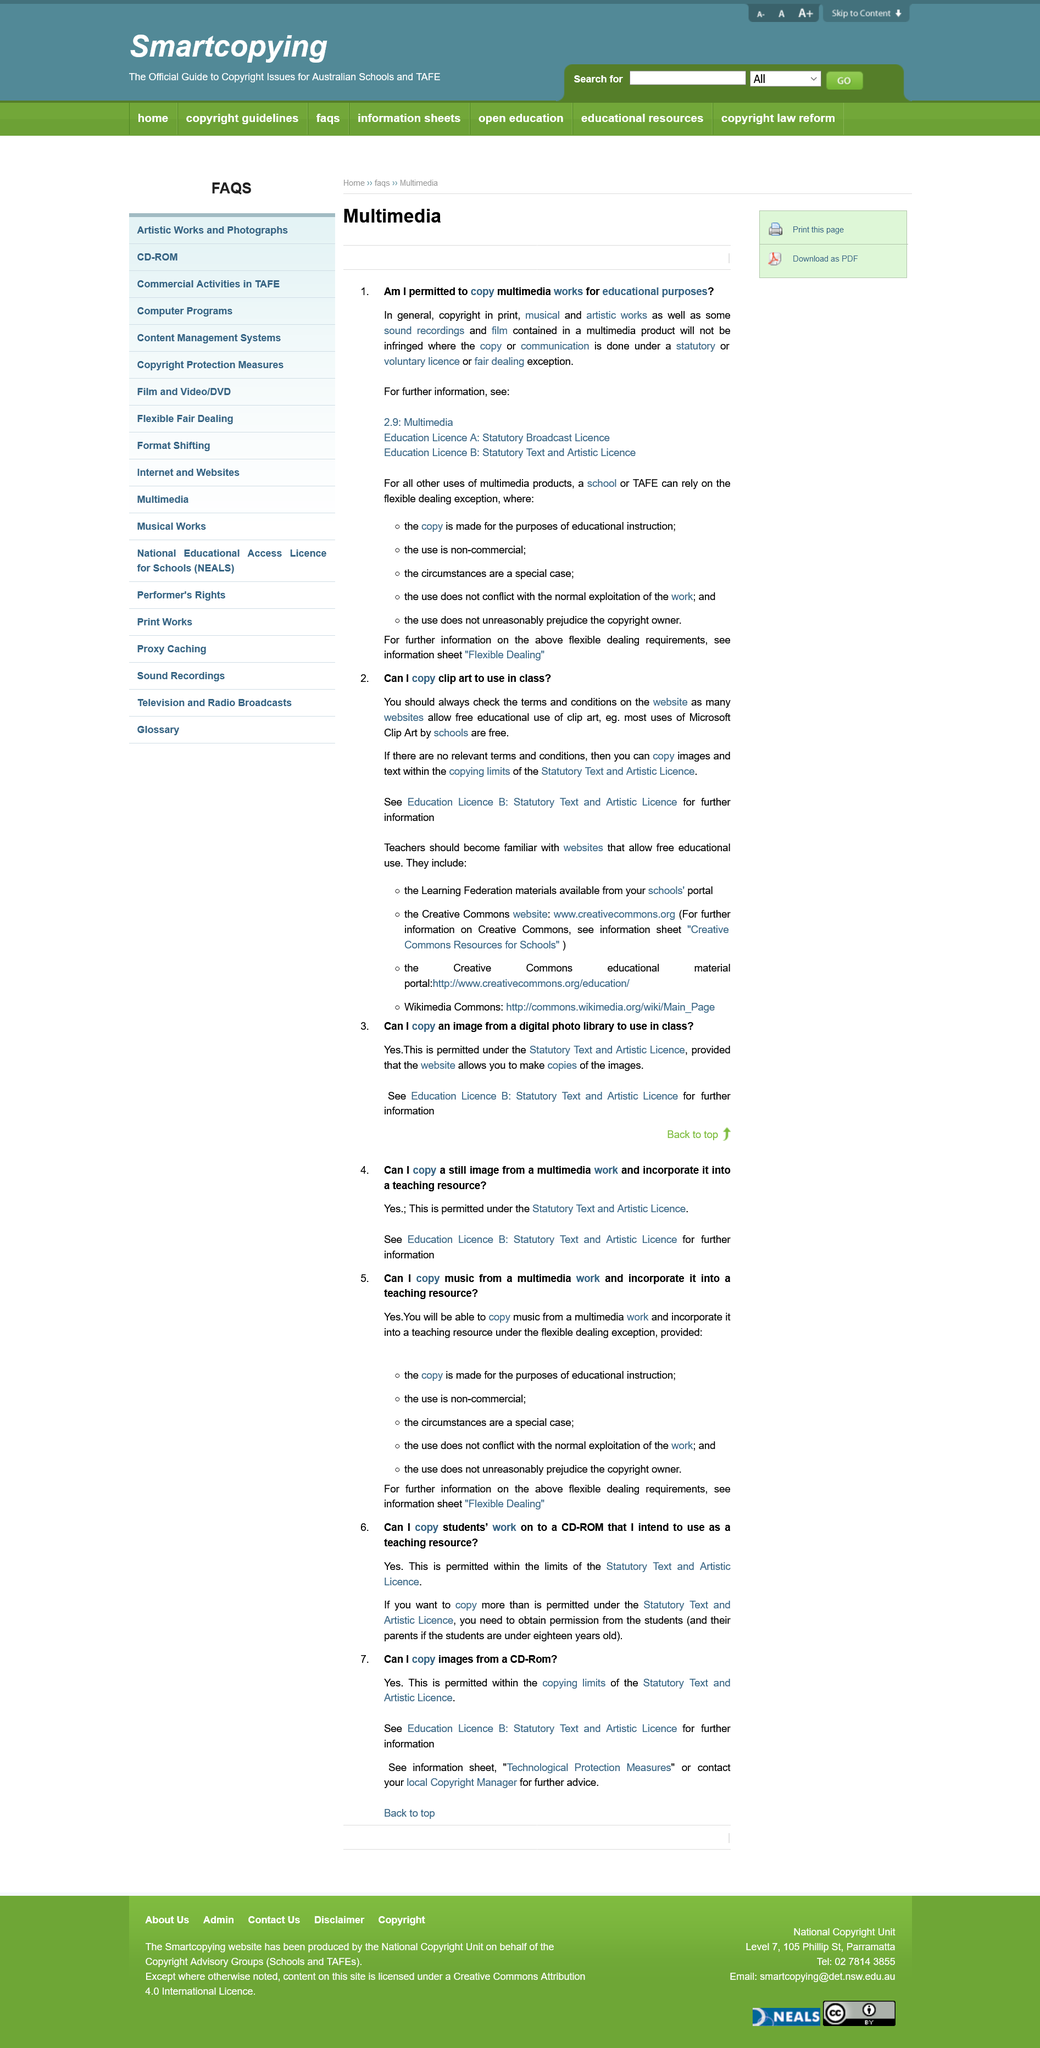Outline some significant characteristics in this image. It is permitted to copy a students' work on to a CD-ROM for use as a teaching resource. In Education Licence A, you will discover a wealth of information regarding the Statutory Broadcast Licence. It is not permissible to use music from a multimedia work for commercial purposes if it has been copied, and it is only permissible to use it for non-commercial purposes if it has been lawfully acquired. Flexible Dealing is the information sheet that provides information on flexible dealing requirements. No school of TAFE can rely on the flexible dealing exception if the use is non-commercial. 